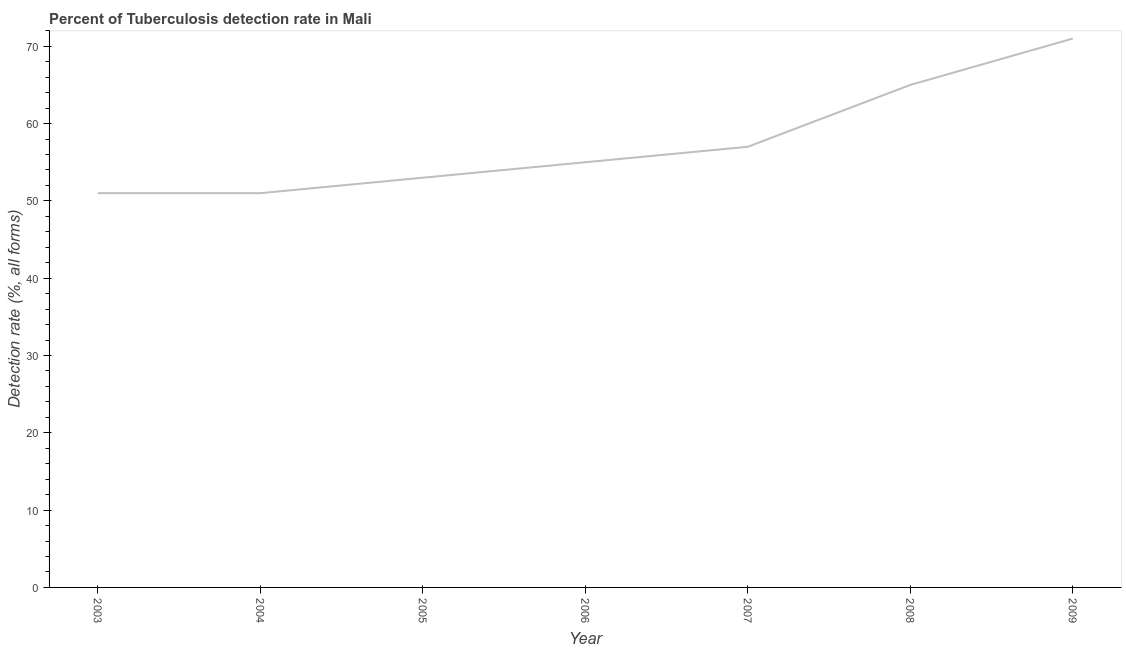What is the detection rate of tuberculosis in 2007?
Provide a succinct answer. 57. Across all years, what is the maximum detection rate of tuberculosis?
Give a very brief answer. 71. Across all years, what is the minimum detection rate of tuberculosis?
Your answer should be compact. 51. In which year was the detection rate of tuberculosis maximum?
Offer a terse response. 2009. In which year was the detection rate of tuberculosis minimum?
Ensure brevity in your answer.  2003. What is the sum of the detection rate of tuberculosis?
Give a very brief answer. 403. What is the difference between the detection rate of tuberculosis in 2008 and 2009?
Provide a succinct answer. -6. What is the average detection rate of tuberculosis per year?
Provide a short and direct response. 57.57. What is the median detection rate of tuberculosis?
Give a very brief answer. 55. In how many years, is the detection rate of tuberculosis greater than 68 %?
Offer a very short reply. 1. Do a majority of the years between 2004 and 2007 (inclusive) have detection rate of tuberculosis greater than 32 %?
Your answer should be compact. Yes. What is the ratio of the detection rate of tuberculosis in 2006 to that in 2009?
Make the answer very short. 0.77. Is the detection rate of tuberculosis in 2004 less than that in 2008?
Give a very brief answer. Yes. Is the difference between the detection rate of tuberculosis in 2004 and 2008 greater than the difference between any two years?
Your response must be concise. No. What is the difference between the highest and the second highest detection rate of tuberculosis?
Provide a short and direct response. 6. What is the difference between the highest and the lowest detection rate of tuberculosis?
Provide a succinct answer. 20. In how many years, is the detection rate of tuberculosis greater than the average detection rate of tuberculosis taken over all years?
Your answer should be compact. 2. Does the detection rate of tuberculosis monotonically increase over the years?
Make the answer very short. No. What is the difference between two consecutive major ticks on the Y-axis?
Provide a succinct answer. 10. Does the graph contain any zero values?
Make the answer very short. No. What is the title of the graph?
Your answer should be compact. Percent of Tuberculosis detection rate in Mali. What is the label or title of the X-axis?
Keep it short and to the point. Year. What is the label or title of the Y-axis?
Your response must be concise. Detection rate (%, all forms). What is the Detection rate (%, all forms) in 2003?
Offer a terse response. 51. What is the Detection rate (%, all forms) in 2006?
Offer a terse response. 55. What is the Detection rate (%, all forms) in 2008?
Give a very brief answer. 65. What is the Detection rate (%, all forms) in 2009?
Keep it short and to the point. 71. What is the difference between the Detection rate (%, all forms) in 2003 and 2004?
Provide a short and direct response. 0. What is the difference between the Detection rate (%, all forms) in 2003 and 2005?
Offer a very short reply. -2. What is the difference between the Detection rate (%, all forms) in 2003 and 2007?
Keep it short and to the point. -6. What is the difference between the Detection rate (%, all forms) in 2003 and 2008?
Provide a short and direct response. -14. What is the difference between the Detection rate (%, all forms) in 2004 and 2007?
Give a very brief answer. -6. What is the difference between the Detection rate (%, all forms) in 2004 and 2008?
Keep it short and to the point. -14. What is the difference between the Detection rate (%, all forms) in 2004 and 2009?
Give a very brief answer. -20. What is the difference between the Detection rate (%, all forms) in 2005 and 2007?
Provide a succinct answer. -4. What is the difference between the Detection rate (%, all forms) in 2007 and 2009?
Provide a succinct answer. -14. What is the difference between the Detection rate (%, all forms) in 2008 and 2009?
Keep it short and to the point. -6. What is the ratio of the Detection rate (%, all forms) in 2003 to that in 2004?
Give a very brief answer. 1. What is the ratio of the Detection rate (%, all forms) in 2003 to that in 2006?
Ensure brevity in your answer.  0.93. What is the ratio of the Detection rate (%, all forms) in 2003 to that in 2007?
Offer a terse response. 0.9. What is the ratio of the Detection rate (%, all forms) in 2003 to that in 2008?
Keep it short and to the point. 0.79. What is the ratio of the Detection rate (%, all forms) in 2003 to that in 2009?
Your response must be concise. 0.72. What is the ratio of the Detection rate (%, all forms) in 2004 to that in 2005?
Offer a terse response. 0.96. What is the ratio of the Detection rate (%, all forms) in 2004 to that in 2006?
Your answer should be very brief. 0.93. What is the ratio of the Detection rate (%, all forms) in 2004 to that in 2007?
Your answer should be very brief. 0.9. What is the ratio of the Detection rate (%, all forms) in 2004 to that in 2008?
Offer a terse response. 0.79. What is the ratio of the Detection rate (%, all forms) in 2004 to that in 2009?
Ensure brevity in your answer.  0.72. What is the ratio of the Detection rate (%, all forms) in 2005 to that in 2007?
Offer a terse response. 0.93. What is the ratio of the Detection rate (%, all forms) in 2005 to that in 2008?
Provide a short and direct response. 0.81. What is the ratio of the Detection rate (%, all forms) in 2005 to that in 2009?
Your response must be concise. 0.75. What is the ratio of the Detection rate (%, all forms) in 2006 to that in 2007?
Keep it short and to the point. 0.96. What is the ratio of the Detection rate (%, all forms) in 2006 to that in 2008?
Keep it short and to the point. 0.85. What is the ratio of the Detection rate (%, all forms) in 2006 to that in 2009?
Give a very brief answer. 0.78. What is the ratio of the Detection rate (%, all forms) in 2007 to that in 2008?
Your response must be concise. 0.88. What is the ratio of the Detection rate (%, all forms) in 2007 to that in 2009?
Your response must be concise. 0.8. What is the ratio of the Detection rate (%, all forms) in 2008 to that in 2009?
Offer a terse response. 0.92. 